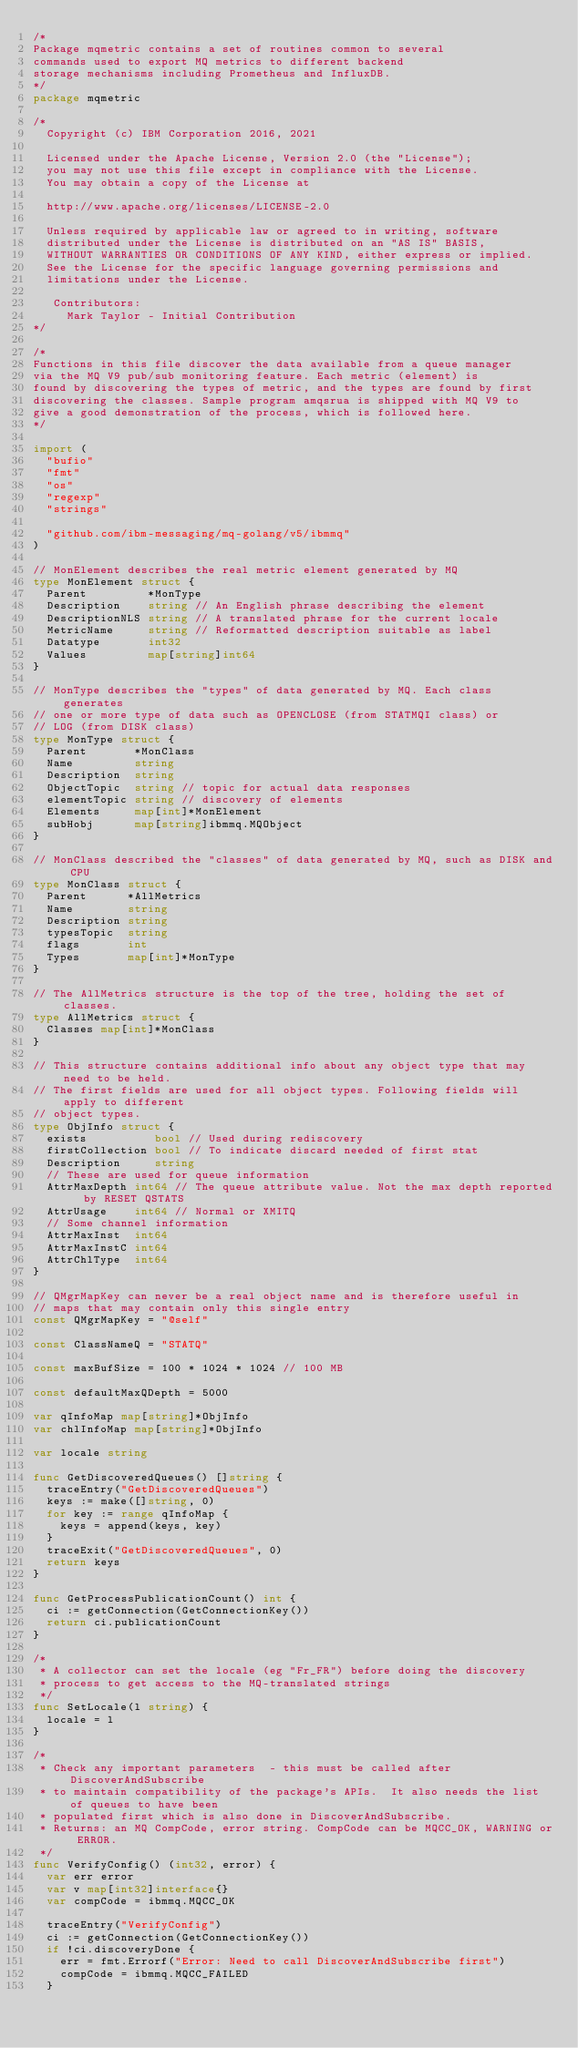Convert code to text. <code><loc_0><loc_0><loc_500><loc_500><_Go_>/*
Package mqmetric contains a set of routines common to several
commands used to export MQ metrics to different backend
storage mechanisms including Prometheus and InfluxDB.
*/
package mqmetric

/*
  Copyright (c) IBM Corporation 2016, 2021

  Licensed under the Apache License, Version 2.0 (the "License");
  you may not use this file except in compliance with the License.
  You may obtain a copy of the License at

  http://www.apache.org/licenses/LICENSE-2.0

  Unless required by applicable law or agreed to in writing, software
  distributed under the License is distributed on an "AS IS" BASIS,
  WITHOUT WARRANTIES OR CONDITIONS OF ANY KIND, either express or implied.
  See the License for the specific language governing permissions and
  limitations under the License.

   Contributors:
     Mark Taylor - Initial Contribution
*/

/*
Functions in this file discover the data available from a queue manager
via the MQ V9 pub/sub monitoring feature. Each metric (element) is
found by discovering the types of metric, and the types are found by first
discovering the classes. Sample program amqsrua is shipped with MQ V9 to
give a good demonstration of the process, which is followed here.
*/

import (
	"bufio"
	"fmt"
	"os"
	"regexp"
	"strings"

	"github.com/ibm-messaging/mq-golang/v5/ibmmq"
)

// MonElement describes the real metric element generated by MQ
type MonElement struct {
	Parent         *MonType
	Description    string // An English phrase describing the element
	DescriptionNLS string // A translated phrase for the current locale
	MetricName     string // Reformatted description suitable as label
	Datatype       int32
	Values         map[string]int64
}

// MonType describes the "types" of data generated by MQ. Each class generates
// one or more type of data such as OPENCLOSE (from STATMQI class) or
// LOG (from DISK class)
type MonType struct {
	Parent       *MonClass
	Name         string
	Description  string
	ObjectTopic  string // topic for actual data responses
	elementTopic string // discovery of elements
	Elements     map[int]*MonElement
	subHobj      map[string]ibmmq.MQObject
}

// MonClass described the "classes" of data generated by MQ, such as DISK and CPU
type MonClass struct {
	Parent      *AllMetrics
	Name        string
	Description string
	typesTopic  string
	flags       int
	Types       map[int]*MonType
}

// The AllMetrics structure is the top of the tree, holding the set of classes.
type AllMetrics struct {
	Classes map[int]*MonClass
}

// This structure contains additional info about any object type that may need to be held.
// The first fields are used for all object types. Following fields will apply to different
// object types.
type ObjInfo struct {
	exists          bool // Used during rediscovery
	firstCollection bool // To indicate discard needed of first stat
	Description     string
	// These are used for queue information
	AttrMaxDepth int64 // The queue attribute value. Not the max depth reported by RESET QSTATS
	AttrUsage    int64 // Normal or XMITQ
	// Some channel information
	AttrMaxInst  int64
	AttrMaxInstC int64
	AttrChlType  int64
}

// QMgrMapKey can never be a real object name and is therefore useful in
// maps that may contain only this single entry
const QMgrMapKey = "@self"

const ClassNameQ = "STATQ"

const maxBufSize = 100 * 1024 * 1024 // 100 MB

const defaultMaxQDepth = 5000

var qInfoMap map[string]*ObjInfo
var chlInfoMap map[string]*ObjInfo

var locale string

func GetDiscoveredQueues() []string {
	traceEntry("GetDiscoveredQueues")
	keys := make([]string, 0)
	for key := range qInfoMap {
		keys = append(keys, key)
	}
	traceExit("GetDiscoveredQueues", 0)
	return keys
}

func GetProcessPublicationCount() int {
	ci := getConnection(GetConnectionKey())
	return ci.publicationCount
}

/*
 * A collector can set the locale (eg "Fr_FR") before doing the discovery
 * process to get access to the MQ-translated strings
 */
func SetLocale(l string) {
	locale = l
}

/*
 * Check any important parameters  - this must be called after DiscoverAndSubscribe
 * to maintain compatibility of the package's APIs.  It also needs the list of queues to have been
 * populated first which is also done in DiscoverAndSubscribe.
 * Returns: an MQ CompCode, error string. CompCode can be MQCC_OK, WARNING or ERROR.
 */
func VerifyConfig() (int32, error) {
	var err error
	var v map[int32]interface{}
	var compCode = ibmmq.MQCC_OK

	traceEntry("VerifyConfig")
	ci := getConnection(GetConnectionKey())
	if !ci.discoveryDone {
		err = fmt.Errorf("Error: Need to call DiscoverAndSubscribe first")
		compCode = ibmmq.MQCC_FAILED
	}
</code> 